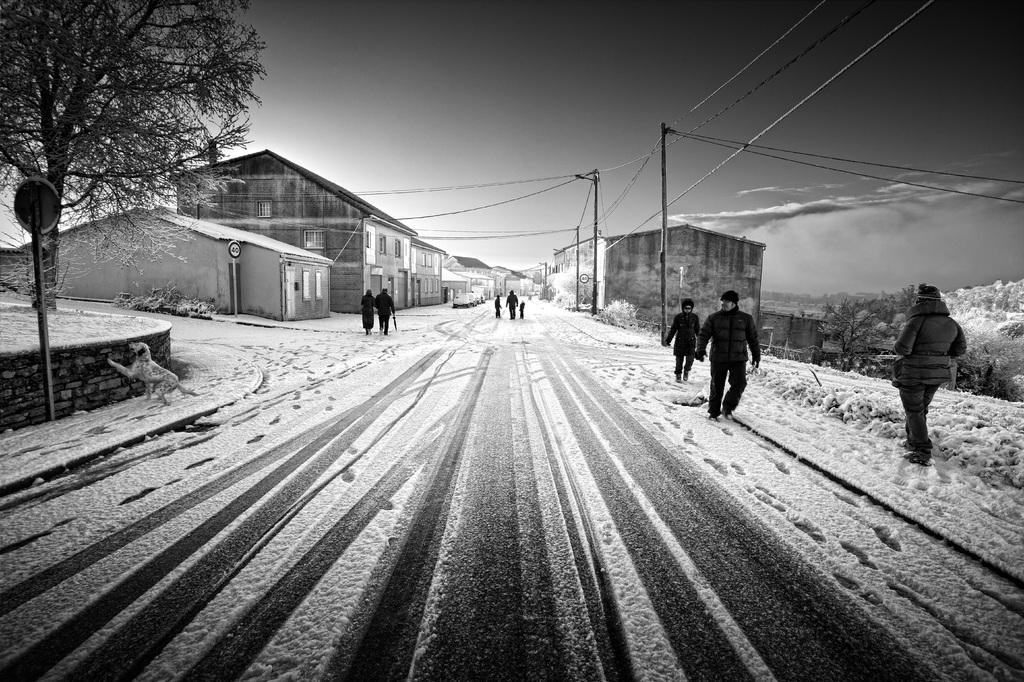How many people are in the image? There is a group of people in the image, but the exact number cannot be determined from the provided facts. What can be seen in the image besides the people? There are poles, cables, buildings, trees, sign boards, and a dog visible in the image. What is the weather like in the image? There is snow in the image, which suggests a cold or wintry environment. What is the color scheme of the image? The image is in black and white. What type of button is being used to control the territory in the image? There is no button or territory mentioned in the image; it features a group of people, poles, cables, buildings, trees, sign boards, snow, and a dog in a black and white setting. 